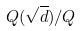Convert formula to latex. <formula><loc_0><loc_0><loc_500><loc_500>Q ( \sqrt { d } ) / Q</formula> 